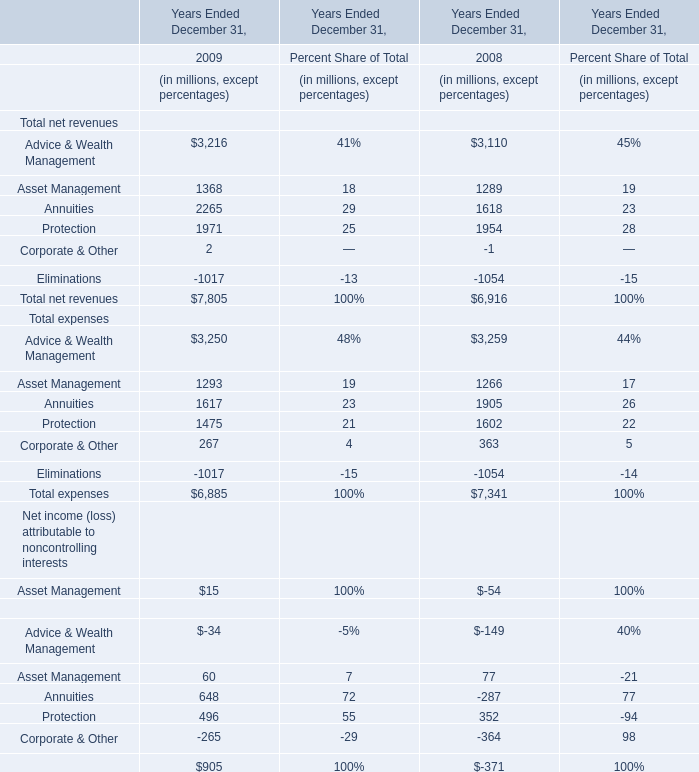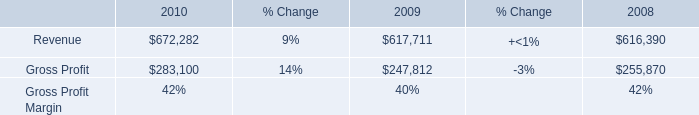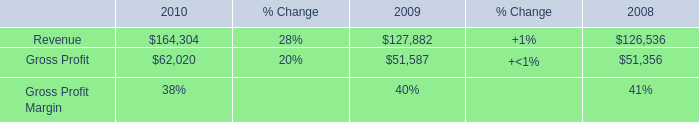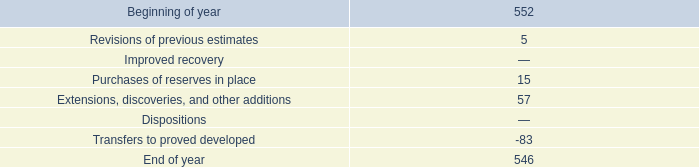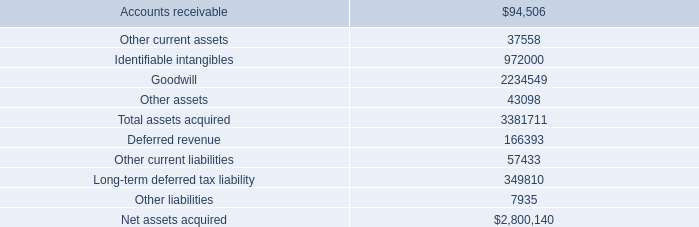what was purchases of reserves in place in 2016? 
Computations: (15 - 28)
Answer: -13.0. 